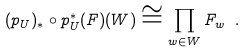Convert formula to latex. <formula><loc_0><loc_0><loc_500><loc_500>( p _ { U } ) _ { * } \circ p _ { U } ^ { * } ( F ) ( W ) \cong \prod _ { w \in W } F _ { w } \ .</formula> 